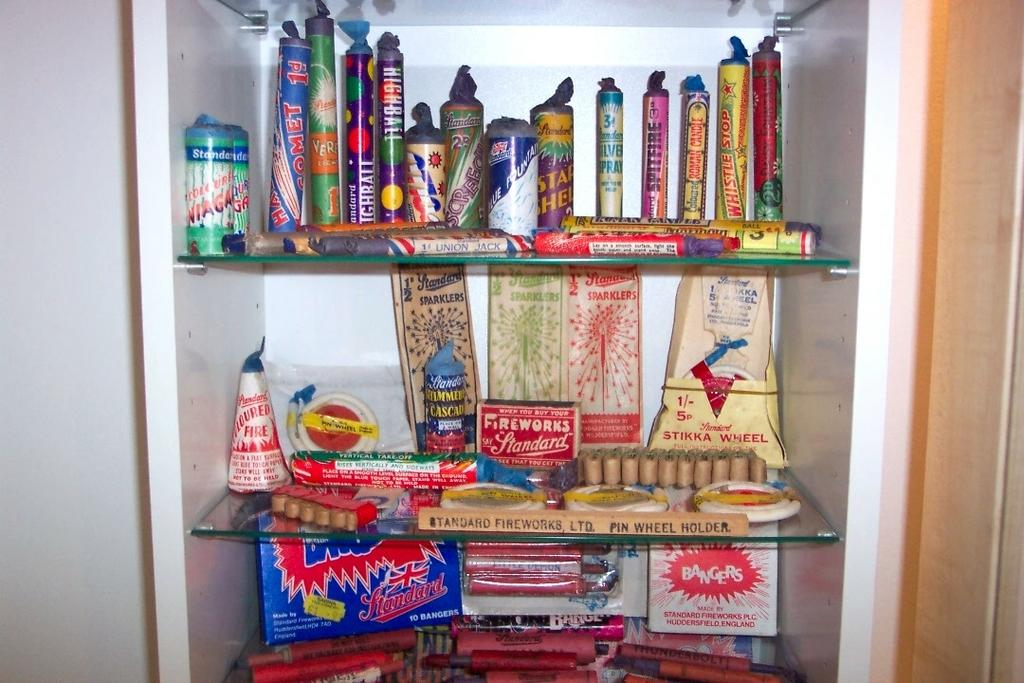What is the main subject of the image? The main subject of the image is different kinds of fireworks. How are the fireworks arranged in the image? The fireworks are arranged on shelves in a cupboard. What type of note is attached to the shoe in the image? There is no shoe or note present in the image; it only features different kinds of fireworks arranged on shelves in a cupboard. 